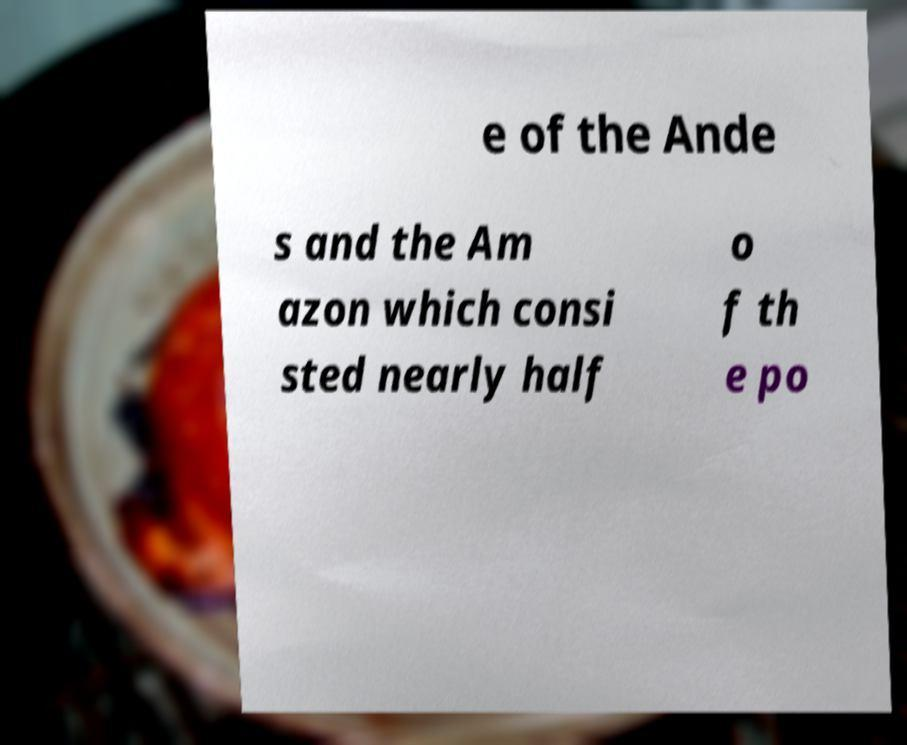Can you accurately transcribe the text from the provided image for me? e of the Ande s and the Am azon which consi sted nearly half o f th e po 